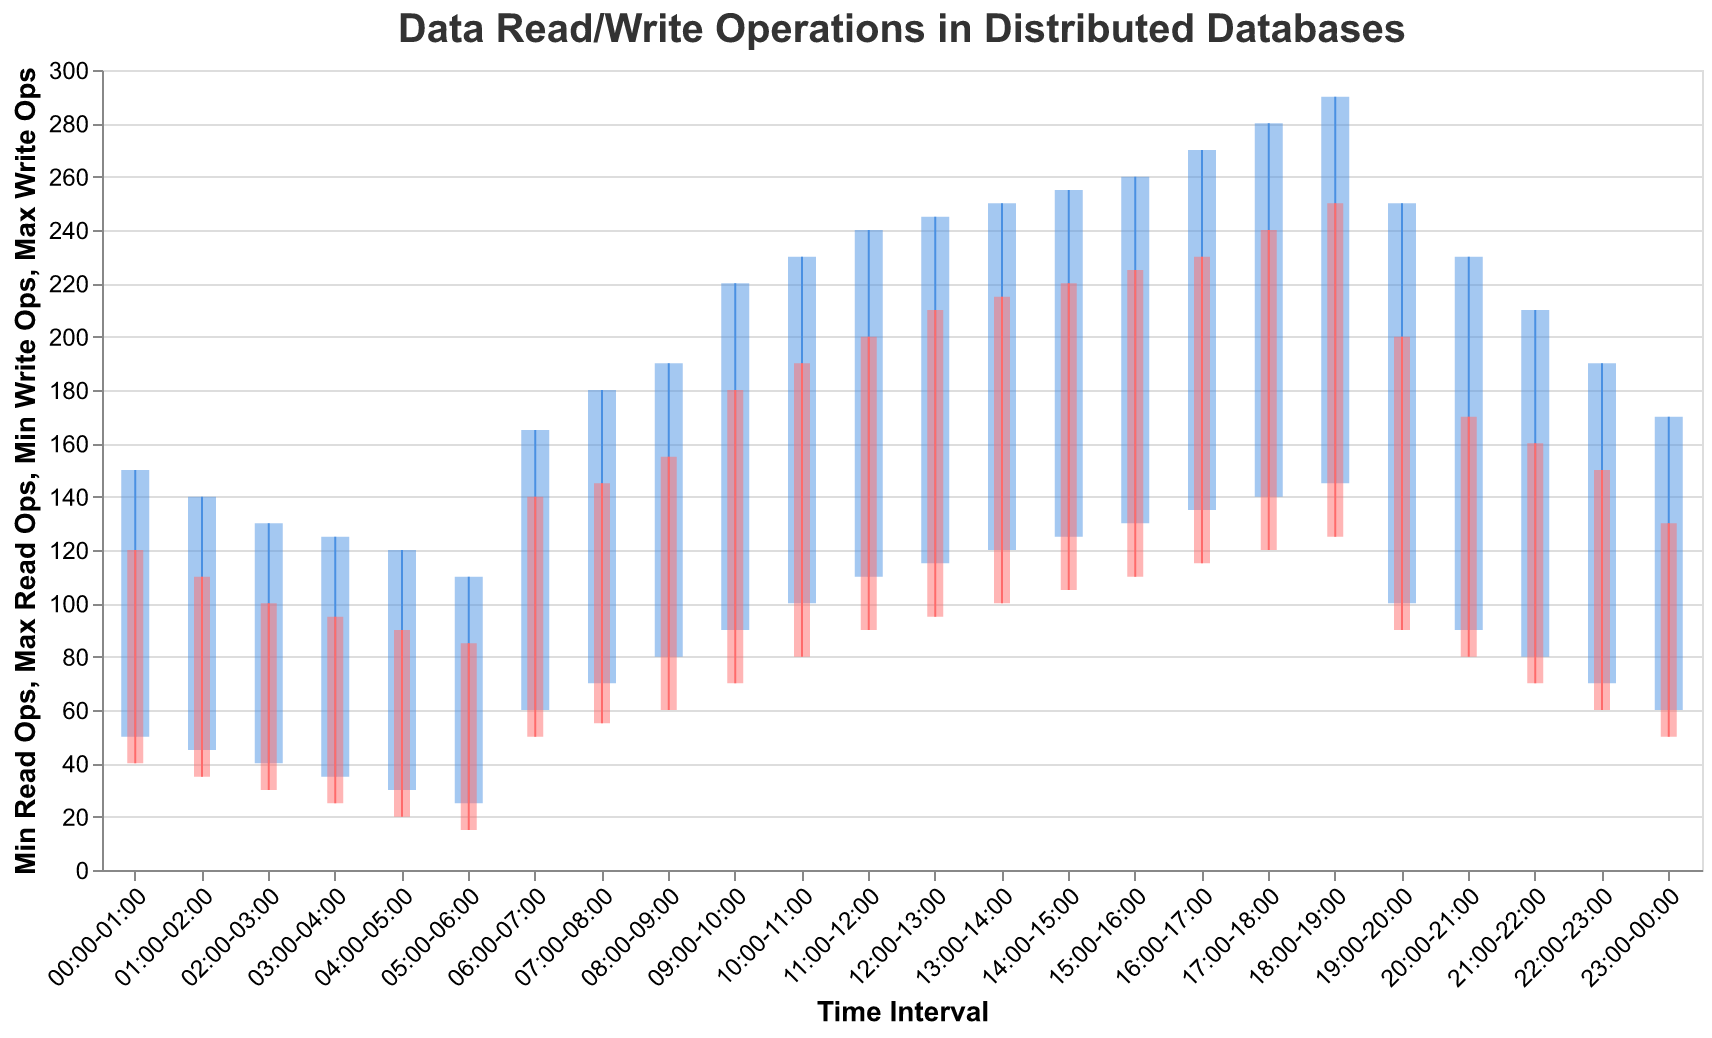What is the title of the figure? The title of the figure is located at the top and summarizes the content of the visualization.
Answer: Data Read/Write Operations in Distributed Databases What time interval has the highest maximum read operations? By looking at the upper end of the blue bars, the interval with the highest maximum read operations is between 18:00 and 19:00, which reaches 290.
Answer: 18:00-19:00 During which time interval do read operations have the lowest minimum value? The interval with the lowest minimum read operations is between 05:00 and 06:00, with a value of 25, identified by the bottom of the blue bars.
Answer: 05:00-06:00 How many data points are there in total? The number of time intervals provided in the data represents the total number of data points, which can be counted directly from the x-axis. There are 24 intervals.
Answer: 24 What time interval shows a significant increase in both read and write operations compared to its previous interval? Both read and write operations see a noticeable increase from the interval 05:00-06:00 to 06:00-07:00, as identified by both blue and red bars increasing substantially.
Answer: 06:00-07:00 Which interval has the smallest range of write operations? By comparing the height of red bars, the interval 03:00-04:00 has the smallest range of write operations, from 25 to 95, amounting to a difference of 70.
Answer: 03:00-04:00 What is the range of read operations in the interval 14:00-15:00? The minimum read operations in this interval are 125 and the maximum is 255, making the range 255 - 125 = 130.
Answer: 130 During which interval are the write operations closest in value? The write operations in the interval 19:00-20:00 are closest, spanning from 90 to 200, a difference of 110.
Answer: 19:00-20:00 How does the minimum read operations at 12:00-13:00 compare to the maximum read operations at 05:00-06:00? The minimum read operations at 12:00-13:00 are 115, which is higher than the maximum read operations at 05:00-06:00, which are 110.
Answer: 115 is higher than 110 